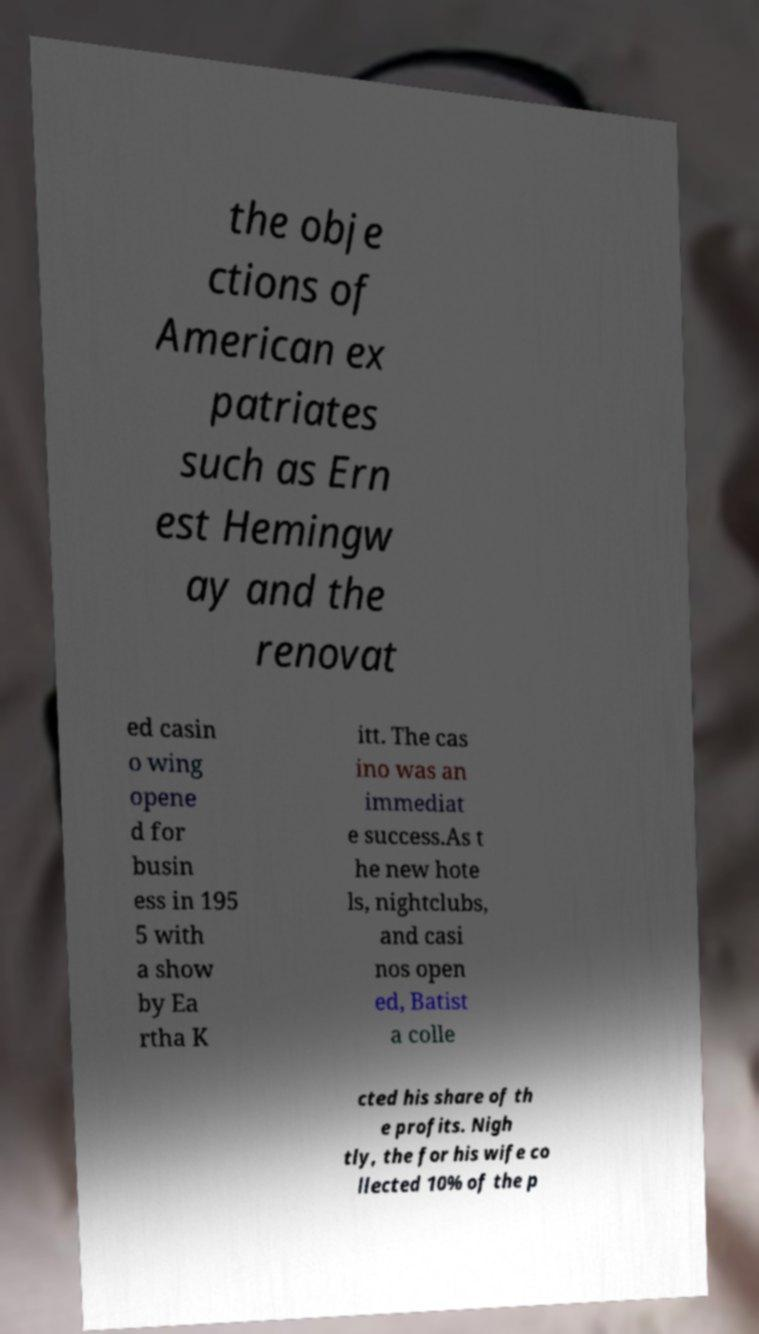For documentation purposes, I need the text within this image transcribed. Could you provide that? the obje ctions of American ex patriates such as Ern est Hemingw ay and the renovat ed casin o wing opene d for busin ess in 195 5 with a show by Ea rtha K itt. The cas ino was an immediat e success.As t he new hote ls, nightclubs, and casi nos open ed, Batist a colle cted his share of th e profits. Nigh tly, the for his wife co llected 10% of the p 